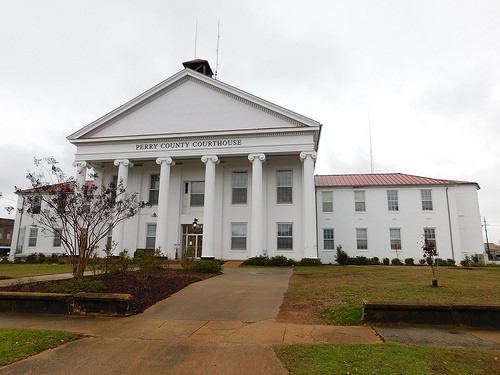<image>
Is the way to the left of the tree? Yes. From this viewpoint, the way is positioned to the left side relative to the tree. Where is the tree in relation to the building? Is it in the building? No. The tree is not contained within the building. These objects have a different spatial relationship. Is there a sidewalk above the grass? No. The sidewalk is not positioned above the grass. The vertical arrangement shows a different relationship. 